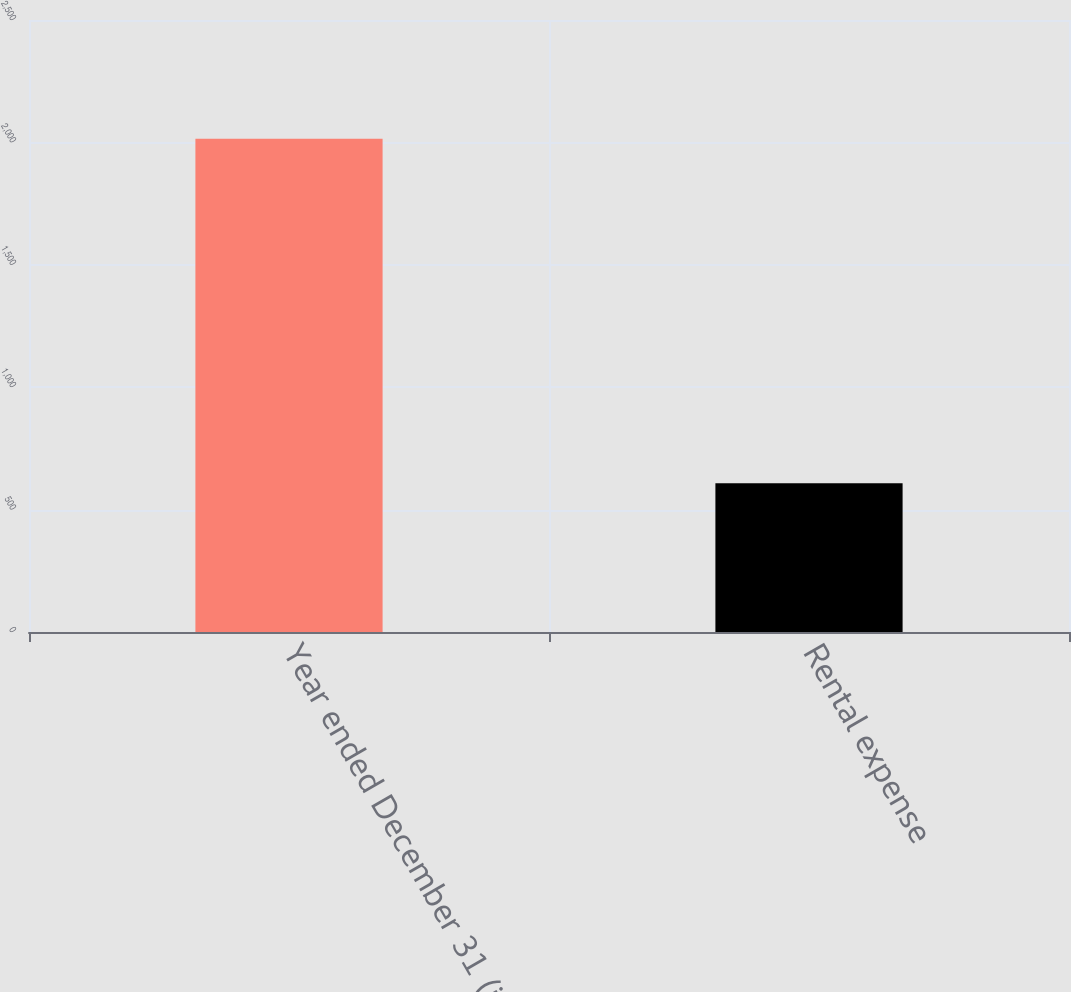<chart> <loc_0><loc_0><loc_500><loc_500><bar_chart><fcel>Year ended December 31 (in<fcel>Rental expense<nl><fcel>2015<fcel>608<nl></chart> 